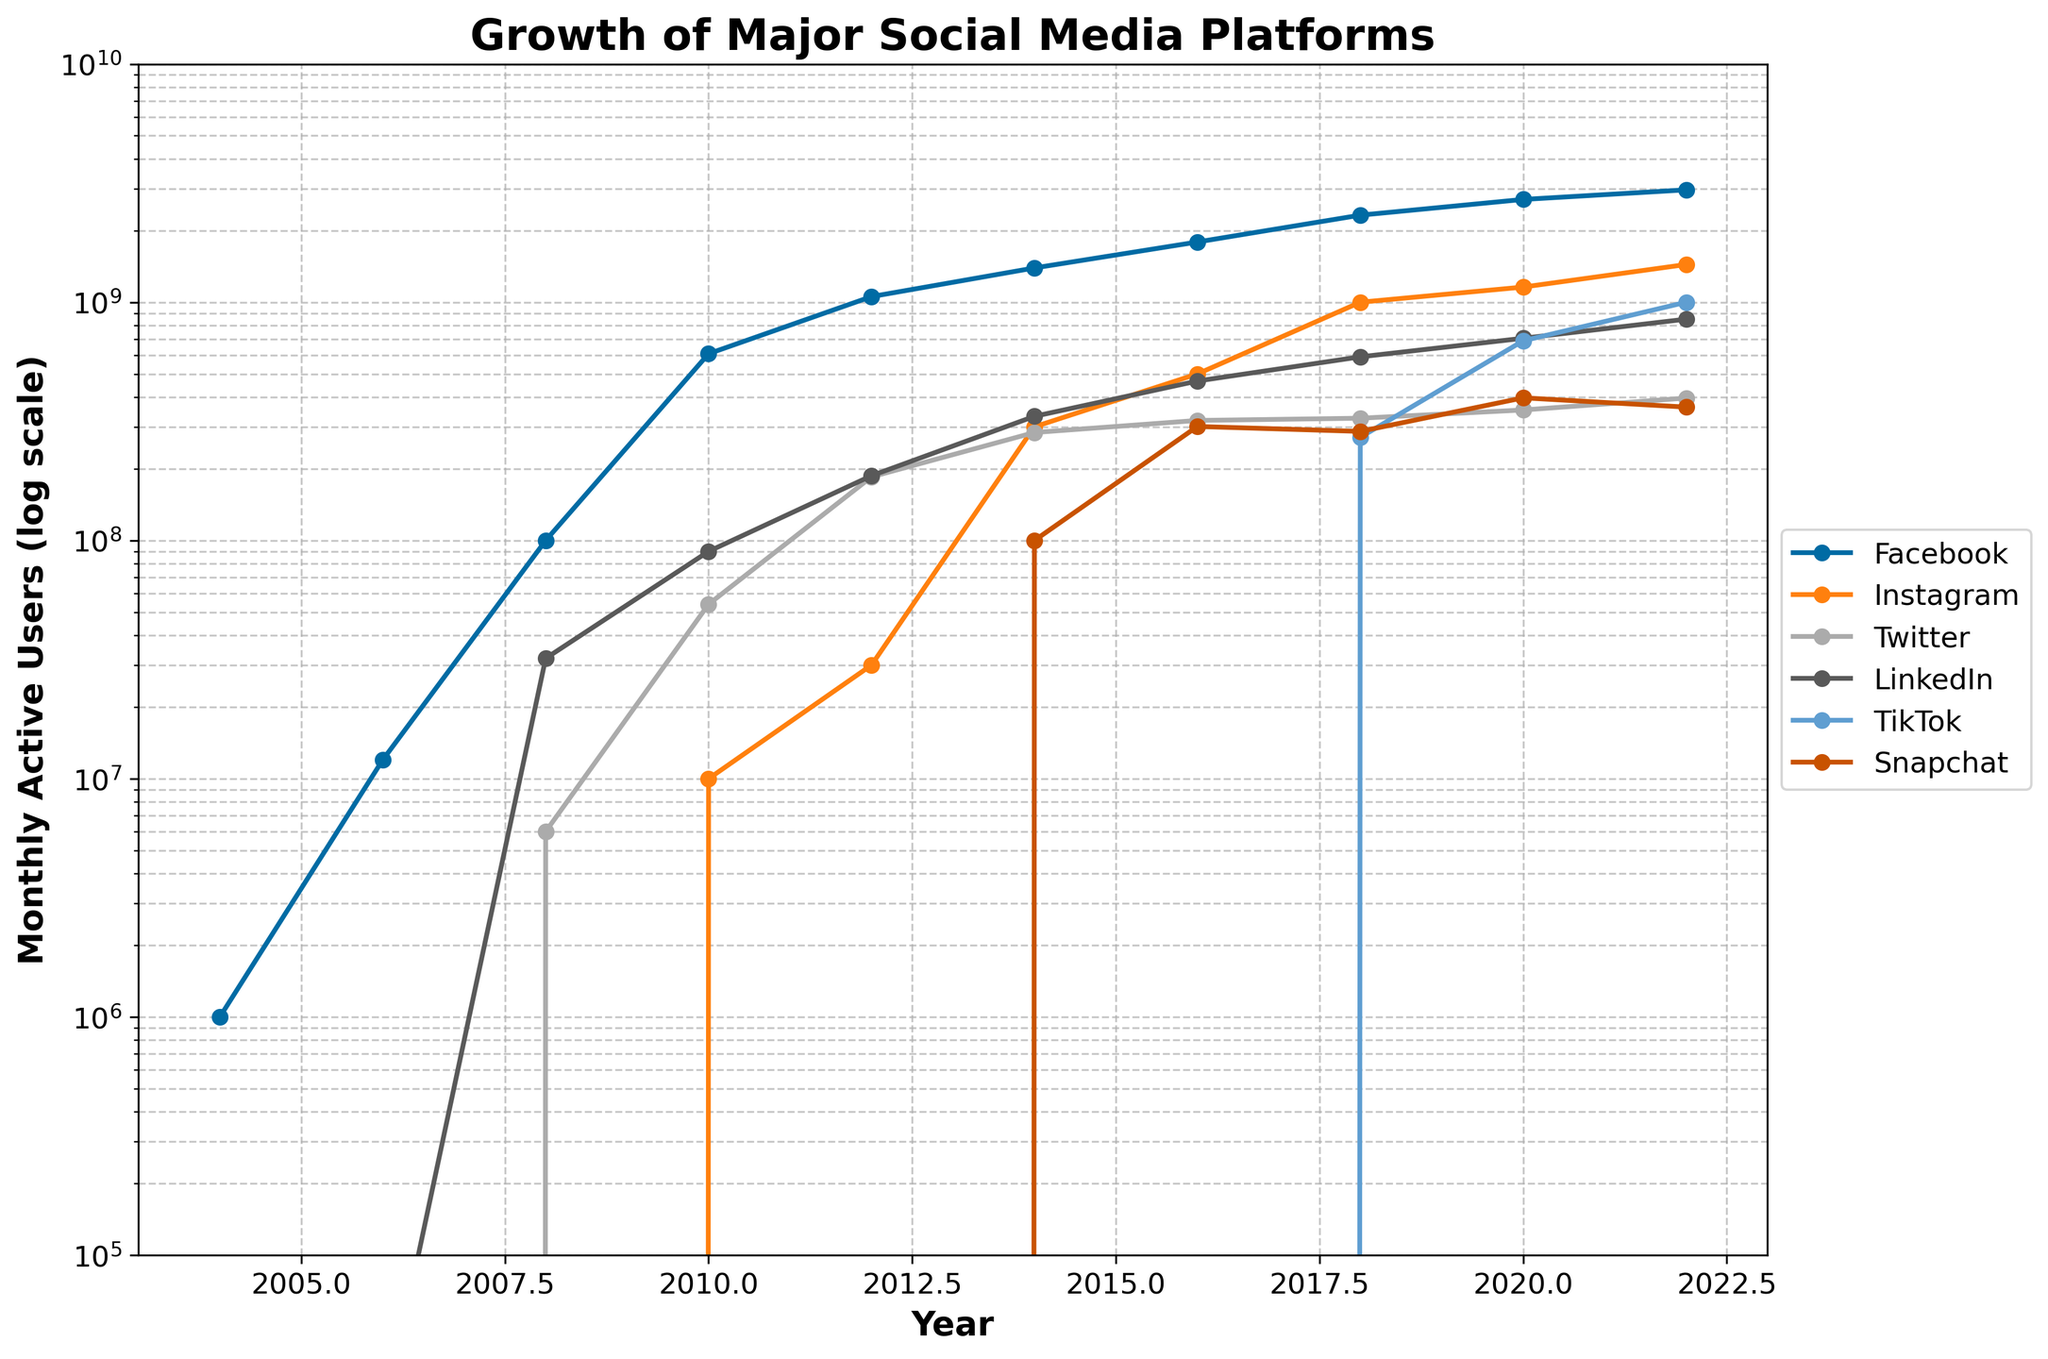When did Instagram reach 1 billion monthly active users? Refer to the figure and find the year in which Instagram's user count first reaches 1 billion.
Answer: 2018 Which platform had the most significant growth between 2008 and 2012? Calculate the difference in user counts for each platform between 2008 (user counts: Facebook 100 million, Instagram 0, Twitter 6 million, LinkedIn 32 million) and 2012 (user counts: Facebook 1.056 billion, Instagram 30 million, Twitter 185 million, LinkedIn 187 million), and determine which platform had the highest value.
Answer: Facebook What can you infer about TikTok's growth compared to Snapchat's from 2018 to 2022? Refer to the plotted lines for TikTok and Snapchat between 2018 (TikTok 271 million, Snapchat 287 million) and 2022 (TikTok 1 billion, Snapchat 363 million). Calculate the increases and compare them. TikTok's user count increased by 729 million, whereas Snapchat's increased by 76 million.
Answer: TikTok grew significantly more than Snapchat Which platform had the highest number of active users in 2022? Refer to the year 2022 on the x-axis and see which line (representing a platform) reaches the highest point (y-axis value).
Answer: Facebook Did LinkedIn or Twitter have more active users in 2016? Look at the lines plotted for LinkedIn and Twitter in the year 2016. LinkedIn had around 467 million, while Twitter had around 319 million.
Answer: LinkedIn Which year marks the intersection point of Instagram and LinkedIn's user growth curves? Observe the intersection points of the lines representing Instagram and LinkedIn. This occurs around 2016, where both have approximately equal user counts due to overlapping lines.
Answer: 2016 By what factor did Facebook's monthly active users increase from 2004 to 2022? Divide the number of Facebook users in 2022 (2.963 billion) by the number in 2004 (1 million). 2.963 billion / 1 million = 2963.
Answer: 2963 Which platform had zero users until 2014 and then showed significant growth? Look at the lines which start at zero until 2014, and then observe a steep incline. This is Snapchat, which shows zero users until 2012 and then rises sharply.
Answer: Snapchat 